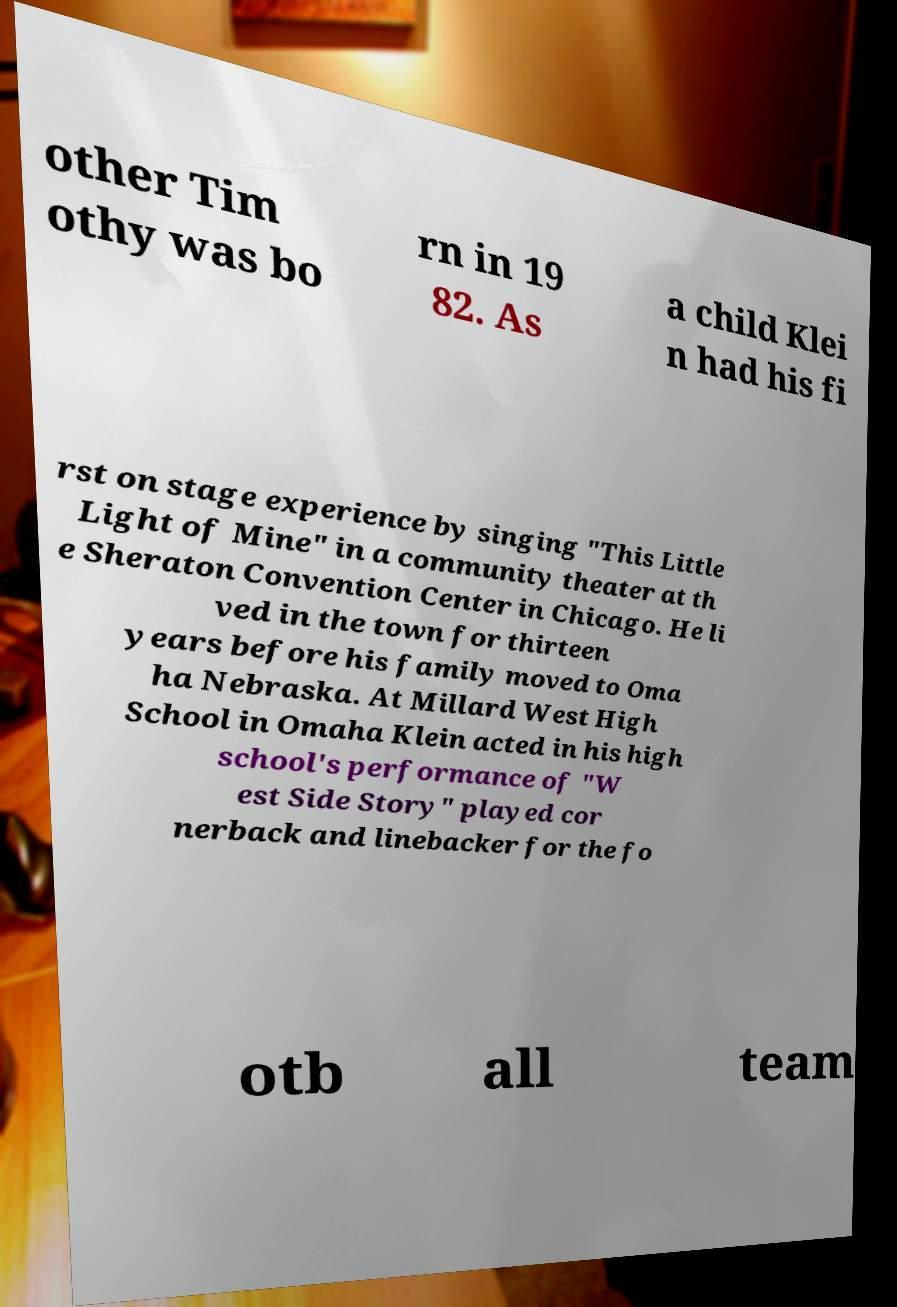Could you extract and type out the text from this image? other Tim othy was bo rn in 19 82. As a child Klei n had his fi rst on stage experience by singing "This Little Light of Mine" in a community theater at th e Sheraton Convention Center in Chicago. He li ved in the town for thirteen years before his family moved to Oma ha Nebraska. At Millard West High School in Omaha Klein acted in his high school's performance of "W est Side Story" played cor nerback and linebacker for the fo otb all team 